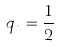Convert formula to latex. <formula><loc_0><loc_0><loc_500><loc_500>q _ { n } = \frac { 1 } { 2 }</formula> 